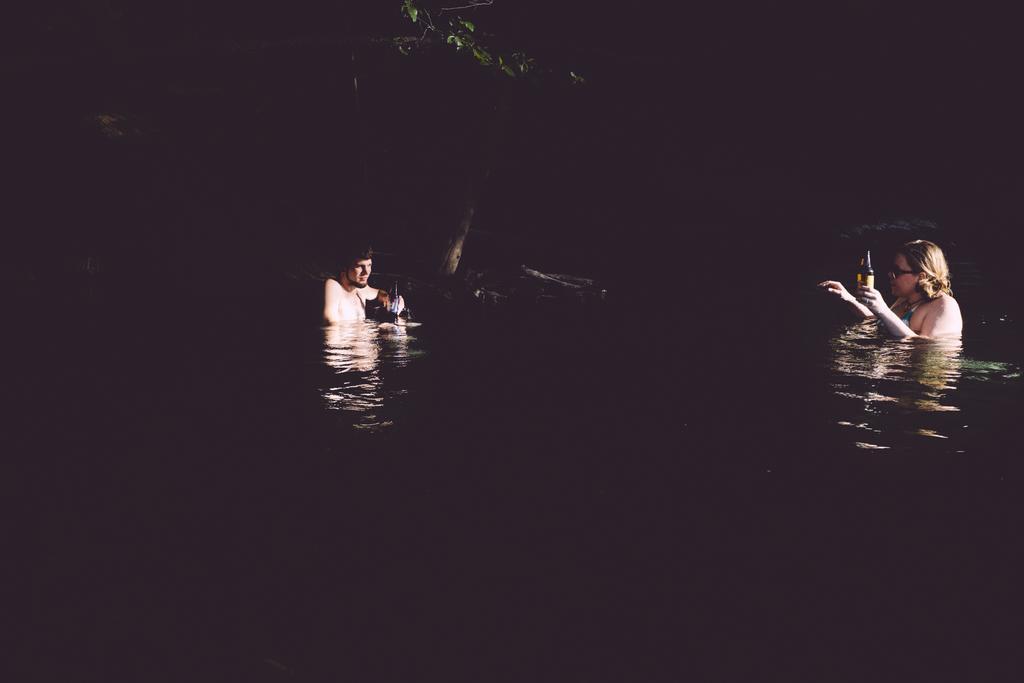Please provide a concise description of this image. In this image there are two people in the water. In the background of the image there is a tree. 